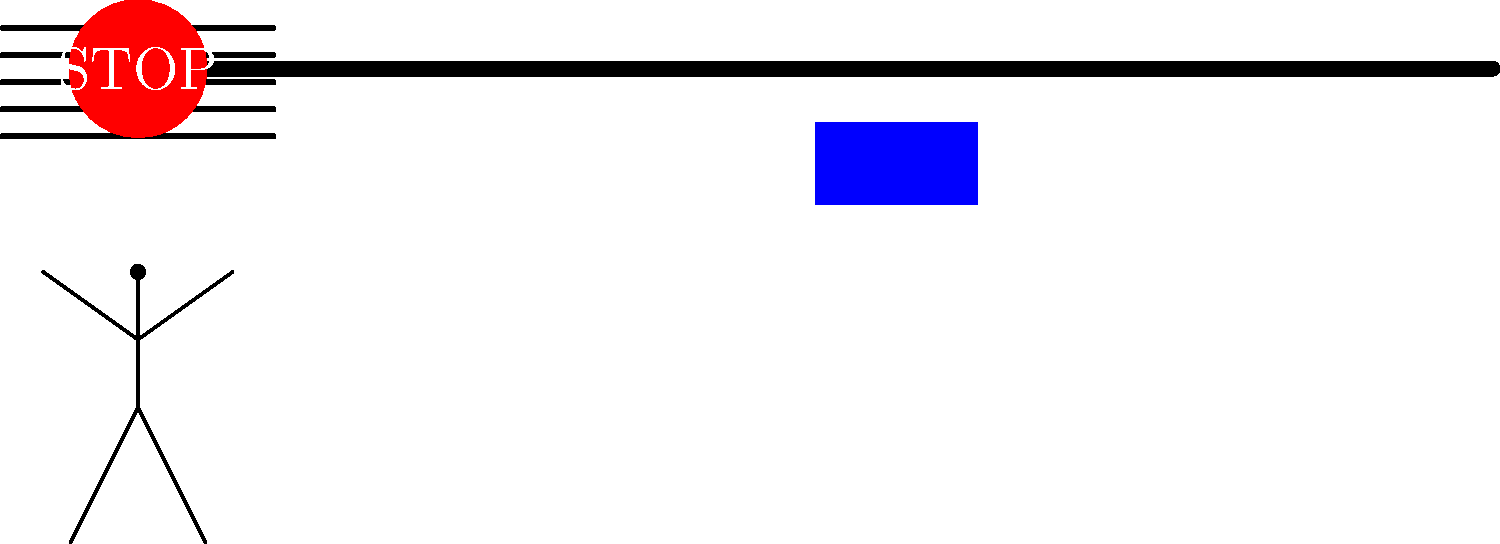Your teenage daughter is approaching a stop sign with a crosswalk, and there's a pedestrian waiting to cross. What should you advise her to do in this situation? Step 1: Recognize the stop sign. The red octagonal sign indicates a full stop is required.

Step 2: Observe the crosswalk. The white lines on the road indicate a designated pedestrian crossing area.

Step 3: Notice the pedestrian. There is a person waiting to cross the street.

Step 4: Understand right-of-way rules. Pedestrians have the right-of-way at marked crosswalks.

Step 5: Determine the correct action:
a) Come to a complete stop at the stop sign.
b) Look both ways for any oncoming traffic.
c) Yield to the pedestrian, allowing them to cross safely.
d) Proceed only when the pedestrian has completely crossed and it's safe to do so.

Step 6: Emphasize the importance of patience and caution, especially as a new driver.
Answer: Stop completely, yield to the pedestrian, and proceed when safe. 